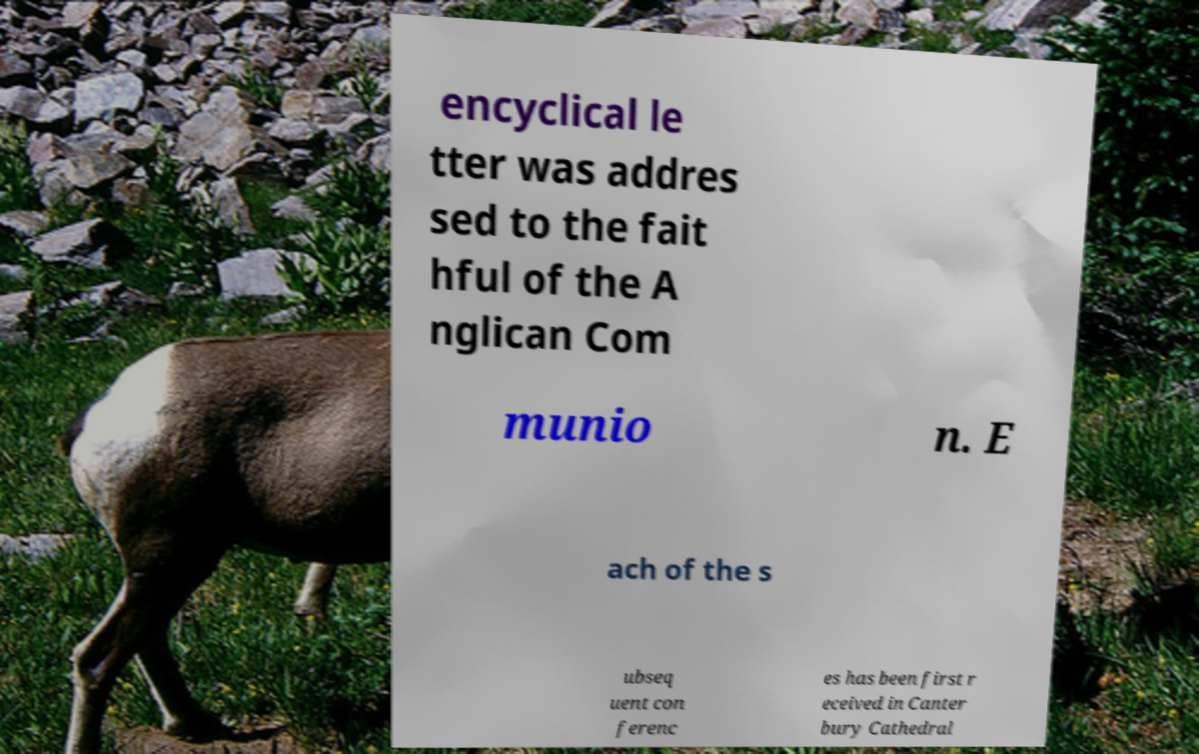For documentation purposes, I need the text within this image transcribed. Could you provide that? encyclical le tter was addres sed to the fait hful of the A nglican Com munio n. E ach of the s ubseq uent con ferenc es has been first r eceived in Canter bury Cathedral 